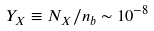Convert formula to latex. <formula><loc_0><loc_0><loc_500><loc_500>Y _ { X } \equiv N _ { X } / n _ { b } \sim 1 0 ^ { - 8 }</formula> 